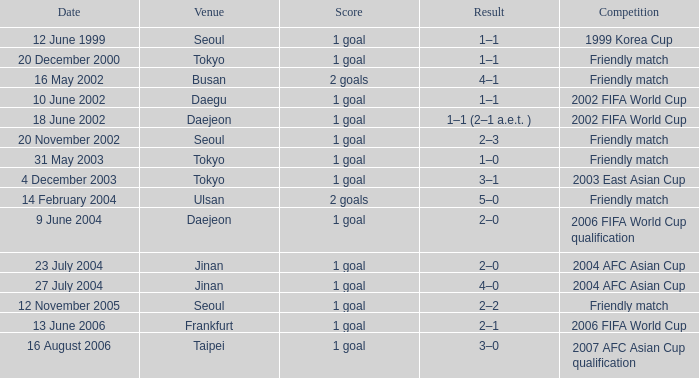What was the result of the match held on 16 august 2006? 1 goal. 